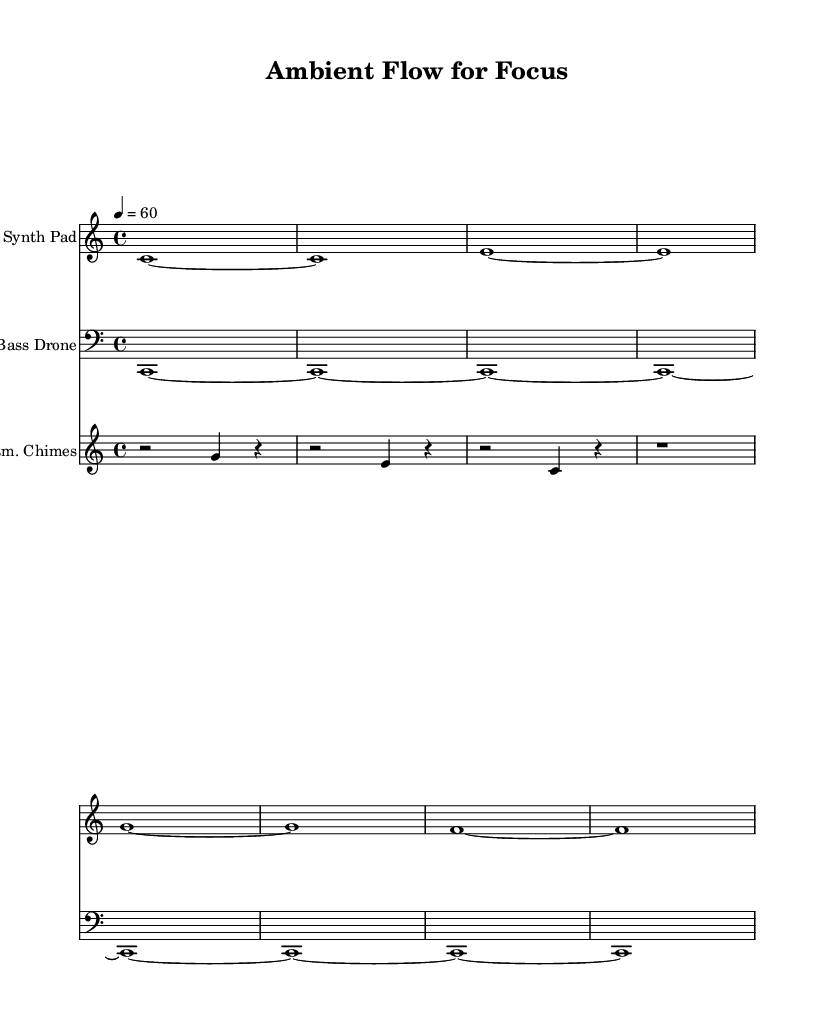What is the key signature of this music? The key signature is C major, which has no sharps or flats.
Answer: C major What is the time signature of this composition? The time signature is indicated by the fraction 4/4, meaning there are four beats per measure.
Answer: 4/4 What is the tempo marking for this piece? The tempo is specified as quarter note equals 60 beats per minute, indicating a slow, steady pace.
Answer: 60 How many distinct instrument parts are present in the score? There are three unique instrument parts shown in the score: "Synth Pad," "Bass Drone," and "Atm. Chimes."
Answer: 3 Which instrument plays the bass line? The bass line is played by the instrument "Bass Drone," which is labeled in the score.
Answer: Bass Drone What is the duration of the first measure in the "Synth Pad" part? The first measure contains a whole note held for the entire measure, indicated with the symbol "c1~."
Answer: Whole note How does the ambient chime pattern contribute to the overall soundscape? The ambient chime pattern creates a light, ethereal texture added to the dense harmonics of the synth and bass, enhancing focus and depth in sound.
Answer: Ethereal texture 